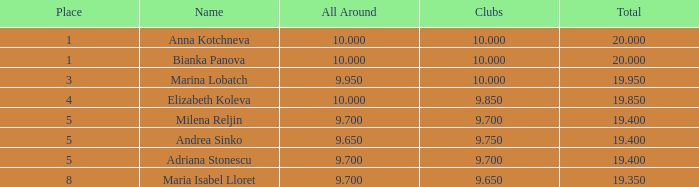What sum consists of 10 in the groups, with a position higher than 1? 19.95. 